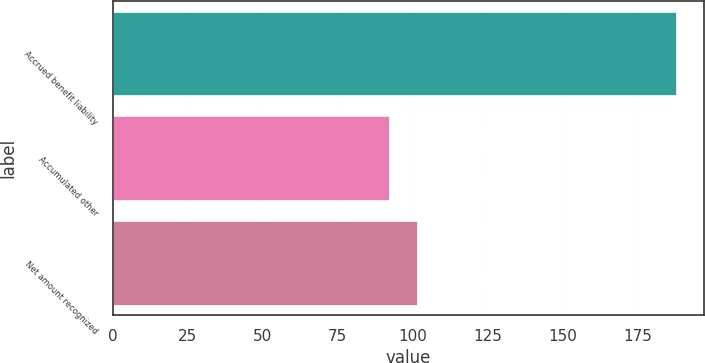Convert chart. <chart><loc_0><loc_0><loc_500><loc_500><bar_chart><fcel>Accrued benefit liability<fcel>Accumulated other<fcel>Net amount recognized<nl><fcel>188<fcel>92<fcel>101.6<nl></chart> 